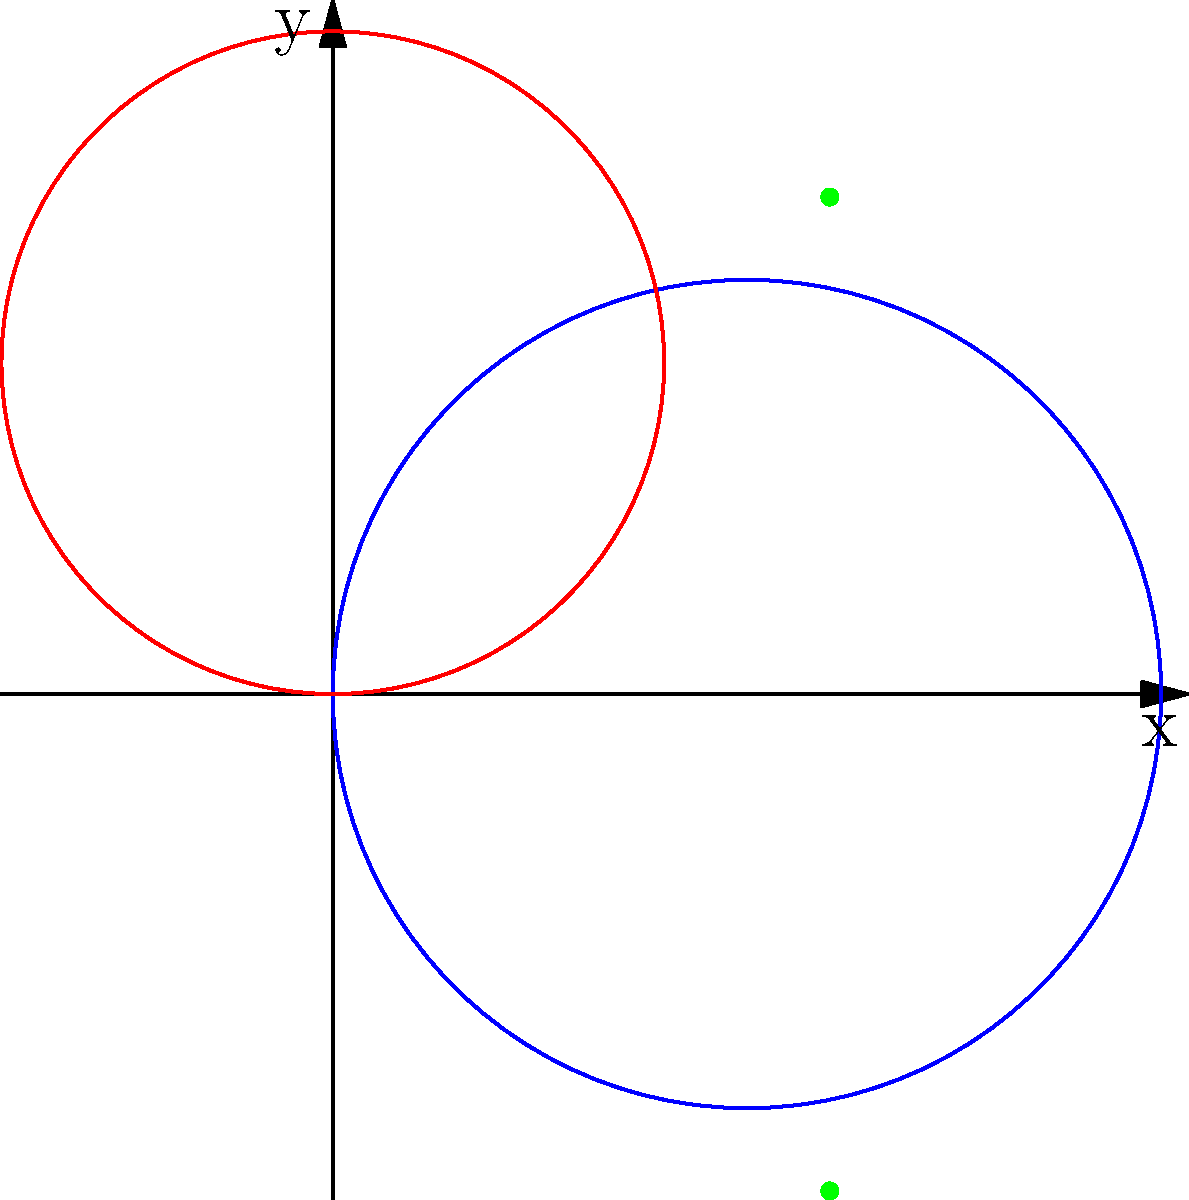In an architectural design, two arches are represented by polar curves. The blue arch is given by the equation $r = 5\cos(\theta)$, and the red arch is given by $r = 4\sin(\theta)$. At what points do these arches intersect? Give your answer in Cartesian coordinates. To find the intersection points, we need to follow these steps:

1) Set the equations equal to each other:
   $5\cos(\theta) = 4\sin(\theta)$

2) Square both sides:
   $25\cos^2(\theta) = 16\sin^2(\theta)$

3) Use the identity $\sin^2(\theta) + \cos^2(\theta) = 1$:
   $25\cos^2(\theta) = 16(1-\cos^2(\theta))$
   $25\cos^2(\theta) = 16 - 16\cos^2(\theta)$

4) Solve for $\cos^2(\theta)$:
   $41\cos^2(\theta) = 16$
   $\cos^2(\theta) = \frac{16}{41}$

5) Take the square root:
   $\cos(\theta) = \pm \frac{4}{\sqrt{41}}$

6) Find $\sin(\theta)$ using $\sin^2(\theta) + \cos^2(\theta) = 1$:
   $\sin(\theta) = \pm \frac{3}{\sqrt{41}}$

7) Convert to Cartesian coordinates using $x = r\cos(\theta)$ and $y = r\sin(\theta)$:
   $x = 5\cos(\theta) = \pm \frac{20}{\sqrt{41}} = \pm 3$
   $y = 5\sin(\theta) = \pm \frac{15}{\sqrt{41}} = \pm 3$

Therefore, the intersection points are $(3,3)$ and $(3,-3)$.
Answer: $(3,3)$ and $(3,-3)$ 